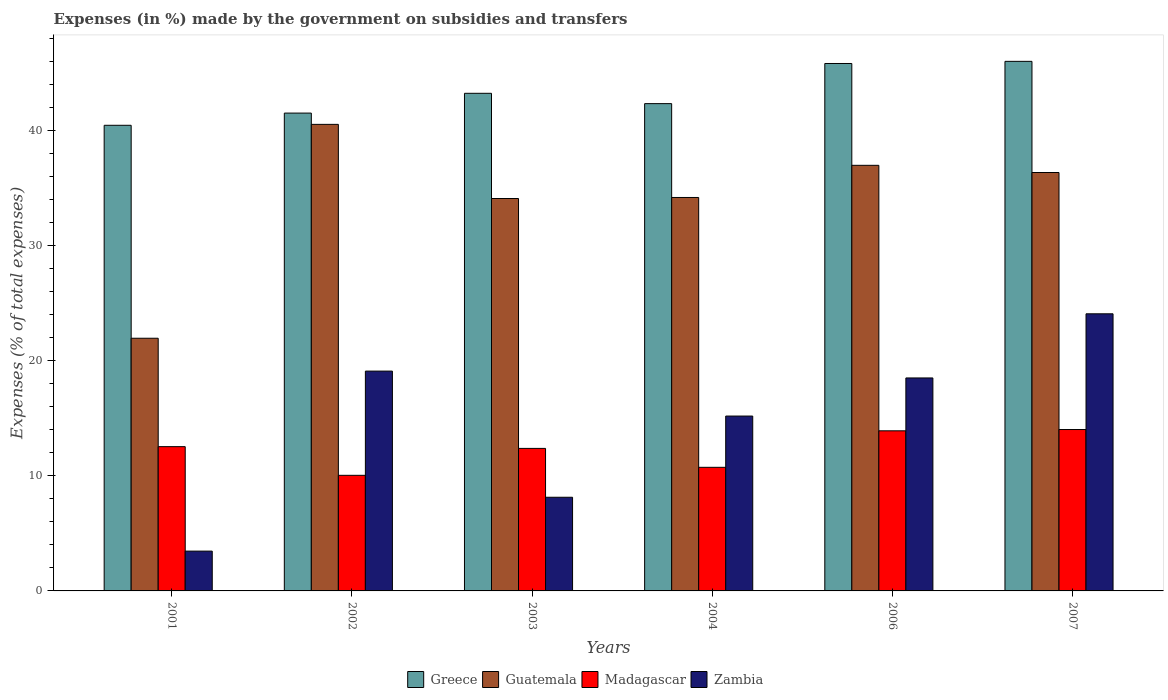How many groups of bars are there?
Your answer should be very brief. 6. Are the number of bars per tick equal to the number of legend labels?
Keep it short and to the point. Yes. How many bars are there on the 3rd tick from the left?
Make the answer very short. 4. What is the percentage of expenses made by the government on subsidies and transfers in Greece in 2007?
Make the answer very short. 46. Across all years, what is the maximum percentage of expenses made by the government on subsidies and transfers in Zambia?
Offer a terse response. 24.07. Across all years, what is the minimum percentage of expenses made by the government on subsidies and transfers in Guatemala?
Your response must be concise. 21.95. In which year was the percentage of expenses made by the government on subsidies and transfers in Zambia maximum?
Keep it short and to the point. 2007. What is the total percentage of expenses made by the government on subsidies and transfers in Zambia in the graph?
Keep it short and to the point. 88.46. What is the difference between the percentage of expenses made by the government on subsidies and transfers in Zambia in 2001 and that in 2006?
Keep it short and to the point. -15.04. What is the difference between the percentage of expenses made by the government on subsidies and transfers in Guatemala in 2003 and the percentage of expenses made by the government on subsidies and transfers in Zambia in 2006?
Provide a short and direct response. 15.59. What is the average percentage of expenses made by the government on subsidies and transfers in Guatemala per year?
Keep it short and to the point. 34.01. In the year 2002, what is the difference between the percentage of expenses made by the government on subsidies and transfers in Zambia and percentage of expenses made by the government on subsidies and transfers in Madagascar?
Ensure brevity in your answer.  9.05. What is the ratio of the percentage of expenses made by the government on subsidies and transfers in Greece in 2001 to that in 2007?
Offer a terse response. 0.88. Is the percentage of expenses made by the government on subsidies and transfers in Guatemala in 2002 less than that in 2004?
Offer a very short reply. No. Is the difference between the percentage of expenses made by the government on subsidies and transfers in Zambia in 2003 and 2006 greater than the difference between the percentage of expenses made by the government on subsidies and transfers in Madagascar in 2003 and 2006?
Make the answer very short. No. What is the difference between the highest and the second highest percentage of expenses made by the government on subsidies and transfers in Guatemala?
Your answer should be compact. 3.56. What is the difference between the highest and the lowest percentage of expenses made by the government on subsidies and transfers in Zambia?
Offer a very short reply. 20.62. What does the 1st bar from the left in 2007 represents?
Your response must be concise. Greece. What does the 2nd bar from the right in 2006 represents?
Give a very brief answer. Madagascar. Is it the case that in every year, the sum of the percentage of expenses made by the government on subsidies and transfers in Madagascar and percentage of expenses made by the government on subsidies and transfers in Greece is greater than the percentage of expenses made by the government on subsidies and transfers in Guatemala?
Provide a succinct answer. Yes. Does the graph contain any zero values?
Offer a very short reply. No. Does the graph contain grids?
Provide a short and direct response. No. What is the title of the graph?
Keep it short and to the point. Expenses (in %) made by the government on subsidies and transfers. What is the label or title of the X-axis?
Your answer should be compact. Years. What is the label or title of the Y-axis?
Provide a succinct answer. Expenses (% of total expenses). What is the Expenses (% of total expenses) in Greece in 2001?
Offer a very short reply. 40.45. What is the Expenses (% of total expenses) in Guatemala in 2001?
Make the answer very short. 21.95. What is the Expenses (% of total expenses) in Madagascar in 2001?
Offer a terse response. 12.53. What is the Expenses (% of total expenses) in Zambia in 2001?
Provide a succinct answer. 3.46. What is the Expenses (% of total expenses) in Greece in 2002?
Give a very brief answer. 41.51. What is the Expenses (% of total expenses) of Guatemala in 2002?
Provide a short and direct response. 40.53. What is the Expenses (% of total expenses) of Madagascar in 2002?
Provide a succinct answer. 10.04. What is the Expenses (% of total expenses) in Zambia in 2002?
Offer a very short reply. 19.1. What is the Expenses (% of total expenses) in Greece in 2003?
Your answer should be compact. 43.23. What is the Expenses (% of total expenses) of Guatemala in 2003?
Provide a short and direct response. 34.09. What is the Expenses (% of total expenses) of Madagascar in 2003?
Provide a short and direct response. 12.38. What is the Expenses (% of total expenses) of Zambia in 2003?
Give a very brief answer. 8.14. What is the Expenses (% of total expenses) in Greece in 2004?
Provide a succinct answer. 42.33. What is the Expenses (% of total expenses) of Guatemala in 2004?
Offer a terse response. 34.18. What is the Expenses (% of total expenses) of Madagascar in 2004?
Give a very brief answer. 10.74. What is the Expenses (% of total expenses) of Zambia in 2004?
Make the answer very short. 15.19. What is the Expenses (% of total expenses) of Greece in 2006?
Provide a succinct answer. 45.82. What is the Expenses (% of total expenses) of Guatemala in 2006?
Offer a very short reply. 36.97. What is the Expenses (% of total expenses) of Madagascar in 2006?
Provide a short and direct response. 13.91. What is the Expenses (% of total expenses) of Zambia in 2006?
Your response must be concise. 18.5. What is the Expenses (% of total expenses) in Greece in 2007?
Your answer should be very brief. 46. What is the Expenses (% of total expenses) in Guatemala in 2007?
Provide a succinct answer. 36.35. What is the Expenses (% of total expenses) in Madagascar in 2007?
Offer a terse response. 14.02. What is the Expenses (% of total expenses) of Zambia in 2007?
Ensure brevity in your answer.  24.07. Across all years, what is the maximum Expenses (% of total expenses) in Greece?
Offer a very short reply. 46. Across all years, what is the maximum Expenses (% of total expenses) of Guatemala?
Keep it short and to the point. 40.53. Across all years, what is the maximum Expenses (% of total expenses) of Madagascar?
Make the answer very short. 14.02. Across all years, what is the maximum Expenses (% of total expenses) of Zambia?
Keep it short and to the point. 24.07. Across all years, what is the minimum Expenses (% of total expenses) of Greece?
Provide a succinct answer. 40.45. Across all years, what is the minimum Expenses (% of total expenses) of Guatemala?
Offer a terse response. 21.95. Across all years, what is the minimum Expenses (% of total expenses) in Madagascar?
Give a very brief answer. 10.04. Across all years, what is the minimum Expenses (% of total expenses) in Zambia?
Offer a very short reply. 3.46. What is the total Expenses (% of total expenses) in Greece in the graph?
Provide a short and direct response. 259.35. What is the total Expenses (% of total expenses) of Guatemala in the graph?
Provide a succinct answer. 204.07. What is the total Expenses (% of total expenses) in Madagascar in the graph?
Your answer should be very brief. 73.62. What is the total Expenses (% of total expenses) in Zambia in the graph?
Ensure brevity in your answer.  88.46. What is the difference between the Expenses (% of total expenses) in Greece in 2001 and that in 2002?
Provide a succinct answer. -1.06. What is the difference between the Expenses (% of total expenses) of Guatemala in 2001 and that in 2002?
Ensure brevity in your answer.  -18.58. What is the difference between the Expenses (% of total expenses) in Madagascar in 2001 and that in 2002?
Your response must be concise. 2.49. What is the difference between the Expenses (% of total expenses) in Zambia in 2001 and that in 2002?
Make the answer very short. -15.64. What is the difference between the Expenses (% of total expenses) in Greece in 2001 and that in 2003?
Your answer should be very brief. -2.78. What is the difference between the Expenses (% of total expenses) in Guatemala in 2001 and that in 2003?
Your answer should be very brief. -12.14. What is the difference between the Expenses (% of total expenses) of Madagascar in 2001 and that in 2003?
Your response must be concise. 0.15. What is the difference between the Expenses (% of total expenses) of Zambia in 2001 and that in 2003?
Provide a short and direct response. -4.68. What is the difference between the Expenses (% of total expenses) of Greece in 2001 and that in 2004?
Provide a short and direct response. -1.88. What is the difference between the Expenses (% of total expenses) in Guatemala in 2001 and that in 2004?
Offer a terse response. -12.23. What is the difference between the Expenses (% of total expenses) in Madagascar in 2001 and that in 2004?
Provide a succinct answer. 1.8. What is the difference between the Expenses (% of total expenses) of Zambia in 2001 and that in 2004?
Give a very brief answer. -11.73. What is the difference between the Expenses (% of total expenses) of Greece in 2001 and that in 2006?
Ensure brevity in your answer.  -5.37. What is the difference between the Expenses (% of total expenses) in Guatemala in 2001 and that in 2006?
Offer a very short reply. -15.02. What is the difference between the Expenses (% of total expenses) in Madagascar in 2001 and that in 2006?
Your answer should be compact. -1.38. What is the difference between the Expenses (% of total expenses) of Zambia in 2001 and that in 2006?
Ensure brevity in your answer.  -15.04. What is the difference between the Expenses (% of total expenses) of Greece in 2001 and that in 2007?
Your answer should be compact. -5.55. What is the difference between the Expenses (% of total expenses) in Guatemala in 2001 and that in 2007?
Provide a short and direct response. -14.4. What is the difference between the Expenses (% of total expenses) of Madagascar in 2001 and that in 2007?
Offer a very short reply. -1.49. What is the difference between the Expenses (% of total expenses) in Zambia in 2001 and that in 2007?
Your answer should be very brief. -20.62. What is the difference between the Expenses (% of total expenses) of Greece in 2002 and that in 2003?
Keep it short and to the point. -1.72. What is the difference between the Expenses (% of total expenses) of Guatemala in 2002 and that in 2003?
Your answer should be compact. 6.44. What is the difference between the Expenses (% of total expenses) of Madagascar in 2002 and that in 2003?
Your answer should be compact. -2.34. What is the difference between the Expenses (% of total expenses) in Zambia in 2002 and that in 2003?
Ensure brevity in your answer.  10.96. What is the difference between the Expenses (% of total expenses) of Greece in 2002 and that in 2004?
Offer a very short reply. -0.82. What is the difference between the Expenses (% of total expenses) in Guatemala in 2002 and that in 2004?
Keep it short and to the point. 6.35. What is the difference between the Expenses (% of total expenses) in Madagascar in 2002 and that in 2004?
Make the answer very short. -0.7. What is the difference between the Expenses (% of total expenses) in Zambia in 2002 and that in 2004?
Offer a terse response. 3.91. What is the difference between the Expenses (% of total expenses) of Greece in 2002 and that in 2006?
Give a very brief answer. -4.31. What is the difference between the Expenses (% of total expenses) of Guatemala in 2002 and that in 2006?
Provide a succinct answer. 3.56. What is the difference between the Expenses (% of total expenses) in Madagascar in 2002 and that in 2006?
Your answer should be compact. -3.87. What is the difference between the Expenses (% of total expenses) of Zambia in 2002 and that in 2006?
Give a very brief answer. 0.6. What is the difference between the Expenses (% of total expenses) in Greece in 2002 and that in 2007?
Keep it short and to the point. -4.49. What is the difference between the Expenses (% of total expenses) in Guatemala in 2002 and that in 2007?
Ensure brevity in your answer.  4.18. What is the difference between the Expenses (% of total expenses) in Madagascar in 2002 and that in 2007?
Offer a very short reply. -3.98. What is the difference between the Expenses (% of total expenses) of Zambia in 2002 and that in 2007?
Keep it short and to the point. -4.98. What is the difference between the Expenses (% of total expenses) of Greece in 2003 and that in 2004?
Your response must be concise. 0.9. What is the difference between the Expenses (% of total expenses) in Guatemala in 2003 and that in 2004?
Make the answer very short. -0.09. What is the difference between the Expenses (% of total expenses) of Madagascar in 2003 and that in 2004?
Your response must be concise. 1.64. What is the difference between the Expenses (% of total expenses) in Zambia in 2003 and that in 2004?
Your response must be concise. -7.05. What is the difference between the Expenses (% of total expenses) in Greece in 2003 and that in 2006?
Your answer should be compact. -2.59. What is the difference between the Expenses (% of total expenses) of Guatemala in 2003 and that in 2006?
Your response must be concise. -2.88. What is the difference between the Expenses (% of total expenses) of Madagascar in 2003 and that in 2006?
Provide a short and direct response. -1.53. What is the difference between the Expenses (% of total expenses) of Zambia in 2003 and that in 2006?
Make the answer very short. -10.36. What is the difference between the Expenses (% of total expenses) in Greece in 2003 and that in 2007?
Your response must be concise. -2.78. What is the difference between the Expenses (% of total expenses) in Guatemala in 2003 and that in 2007?
Make the answer very short. -2.26. What is the difference between the Expenses (% of total expenses) in Madagascar in 2003 and that in 2007?
Offer a terse response. -1.64. What is the difference between the Expenses (% of total expenses) of Zambia in 2003 and that in 2007?
Provide a succinct answer. -15.94. What is the difference between the Expenses (% of total expenses) in Greece in 2004 and that in 2006?
Your response must be concise. -3.49. What is the difference between the Expenses (% of total expenses) of Guatemala in 2004 and that in 2006?
Ensure brevity in your answer.  -2.79. What is the difference between the Expenses (% of total expenses) in Madagascar in 2004 and that in 2006?
Ensure brevity in your answer.  -3.17. What is the difference between the Expenses (% of total expenses) in Zambia in 2004 and that in 2006?
Your answer should be very brief. -3.31. What is the difference between the Expenses (% of total expenses) of Greece in 2004 and that in 2007?
Give a very brief answer. -3.67. What is the difference between the Expenses (% of total expenses) of Guatemala in 2004 and that in 2007?
Keep it short and to the point. -2.17. What is the difference between the Expenses (% of total expenses) of Madagascar in 2004 and that in 2007?
Your answer should be very brief. -3.28. What is the difference between the Expenses (% of total expenses) in Zambia in 2004 and that in 2007?
Make the answer very short. -8.88. What is the difference between the Expenses (% of total expenses) of Greece in 2006 and that in 2007?
Offer a terse response. -0.19. What is the difference between the Expenses (% of total expenses) in Guatemala in 2006 and that in 2007?
Your answer should be compact. 0.62. What is the difference between the Expenses (% of total expenses) in Madagascar in 2006 and that in 2007?
Make the answer very short. -0.11. What is the difference between the Expenses (% of total expenses) of Zambia in 2006 and that in 2007?
Offer a very short reply. -5.57. What is the difference between the Expenses (% of total expenses) of Greece in 2001 and the Expenses (% of total expenses) of Guatemala in 2002?
Offer a very short reply. -0.08. What is the difference between the Expenses (% of total expenses) in Greece in 2001 and the Expenses (% of total expenses) in Madagascar in 2002?
Your answer should be very brief. 30.41. What is the difference between the Expenses (% of total expenses) of Greece in 2001 and the Expenses (% of total expenses) of Zambia in 2002?
Your answer should be compact. 21.35. What is the difference between the Expenses (% of total expenses) in Guatemala in 2001 and the Expenses (% of total expenses) in Madagascar in 2002?
Give a very brief answer. 11.91. What is the difference between the Expenses (% of total expenses) of Guatemala in 2001 and the Expenses (% of total expenses) of Zambia in 2002?
Provide a succinct answer. 2.85. What is the difference between the Expenses (% of total expenses) in Madagascar in 2001 and the Expenses (% of total expenses) in Zambia in 2002?
Your answer should be compact. -6.56. What is the difference between the Expenses (% of total expenses) of Greece in 2001 and the Expenses (% of total expenses) of Guatemala in 2003?
Your answer should be compact. 6.36. What is the difference between the Expenses (% of total expenses) in Greece in 2001 and the Expenses (% of total expenses) in Madagascar in 2003?
Provide a short and direct response. 28.07. What is the difference between the Expenses (% of total expenses) in Greece in 2001 and the Expenses (% of total expenses) in Zambia in 2003?
Your answer should be very brief. 32.31. What is the difference between the Expenses (% of total expenses) of Guatemala in 2001 and the Expenses (% of total expenses) of Madagascar in 2003?
Keep it short and to the point. 9.57. What is the difference between the Expenses (% of total expenses) of Guatemala in 2001 and the Expenses (% of total expenses) of Zambia in 2003?
Provide a succinct answer. 13.81. What is the difference between the Expenses (% of total expenses) in Madagascar in 2001 and the Expenses (% of total expenses) in Zambia in 2003?
Offer a very short reply. 4.4. What is the difference between the Expenses (% of total expenses) in Greece in 2001 and the Expenses (% of total expenses) in Guatemala in 2004?
Your answer should be very brief. 6.27. What is the difference between the Expenses (% of total expenses) of Greece in 2001 and the Expenses (% of total expenses) of Madagascar in 2004?
Give a very brief answer. 29.71. What is the difference between the Expenses (% of total expenses) of Greece in 2001 and the Expenses (% of total expenses) of Zambia in 2004?
Ensure brevity in your answer.  25.26. What is the difference between the Expenses (% of total expenses) of Guatemala in 2001 and the Expenses (% of total expenses) of Madagascar in 2004?
Keep it short and to the point. 11.21. What is the difference between the Expenses (% of total expenses) in Guatemala in 2001 and the Expenses (% of total expenses) in Zambia in 2004?
Ensure brevity in your answer.  6.76. What is the difference between the Expenses (% of total expenses) in Madagascar in 2001 and the Expenses (% of total expenses) in Zambia in 2004?
Provide a succinct answer. -2.66. What is the difference between the Expenses (% of total expenses) in Greece in 2001 and the Expenses (% of total expenses) in Guatemala in 2006?
Offer a terse response. 3.48. What is the difference between the Expenses (% of total expenses) of Greece in 2001 and the Expenses (% of total expenses) of Madagascar in 2006?
Provide a short and direct response. 26.54. What is the difference between the Expenses (% of total expenses) of Greece in 2001 and the Expenses (% of total expenses) of Zambia in 2006?
Make the answer very short. 21.95. What is the difference between the Expenses (% of total expenses) of Guatemala in 2001 and the Expenses (% of total expenses) of Madagascar in 2006?
Keep it short and to the point. 8.04. What is the difference between the Expenses (% of total expenses) in Guatemala in 2001 and the Expenses (% of total expenses) in Zambia in 2006?
Ensure brevity in your answer.  3.45. What is the difference between the Expenses (% of total expenses) of Madagascar in 2001 and the Expenses (% of total expenses) of Zambia in 2006?
Provide a succinct answer. -5.97. What is the difference between the Expenses (% of total expenses) of Greece in 2001 and the Expenses (% of total expenses) of Guatemala in 2007?
Give a very brief answer. 4.1. What is the difference between the Expenses (% of total expenses) in Greece in 2001 and the Expenses (% of total expenses) in Madagascar in 2007?
Make the answer very short. 26.43. What is the difference between the Expenses (% of total expenses) in Greece in 2001 and the Expenses (% of total expenses) in Zambia in 2007?
Provide a succinct answer. 16.38. What is the difference between the Expenses (% of total expenses) in Guatemala in 2001 and the Expenses (% of total expenses) in Madagascar in 2007?
Keep it short and to the point. 7.93. What is the difference between the Expenses (% of total expenses) of Guatemala in 2001 and the Expenses (% of total expenses) of Zambia in 2007?
Give a very brief answer. -2.12. What is the difference between the Expenses (% of total expenses) of Madagascar in 2001 and the Expenses (% of total expenses) of Zambia in 2007?
Provide a short and direct response. -11.54. What is the difference between the Expenses (% of total expenses) of Greece in 2002 and the Expenses (% of total expenses) of Guatemala in 2003?
Provide a succinct answer. 7.42. What is the difference between the Expenses (% of total expenses) of Greece in 2002 and the Expenses (% of total expenses) of Madagascar in 2003?
Your answer should be compact. 29.13. What is the difference between the Expenses (% of total expenses) of Greece in 2002 and the Expenses (% of total expenses) of Zambia in 2003?
Your response must be concise. 33.37. What is the difference between the Expenses (% of total expenses) of Guatemala in 2002 and the Expenses (% of total expenses) of Madagascar in 2003?
Offer a very short reply. 28.15. What is the difference between the Expenses (% of total expenses) of Guatemala in 2002 and the Expenses (% of total expenses) of Zambia in 2003?
Make the answer very short. 32.39. What is the difference between the Expenses (% of total expenses) in Madagascar in 2002 and the Expenses (% of total expenses) in Zambia in 2003?
Make the answer very short. 1.91. What is the difference between the Expenses (% of total expenses) in Greece in 2002 and the Expenses (% of total expenses) in Guatemala in 2004?
Provide a succinct answer. 7.33. What is the difference between the Expenses (% of total expenses) in Greece in 2002 and the Expenses (% of total expenses) in Madagascar in 2004?
Ensure brevity in your answer.  30.77. What is the difference between the Expenses (% of total expenses) in Greece in 2002 and the Expenses (% of total expenses) in Zambia in 2004?
Ensure brevity in your answer.  26.32. What is the difference between the Expenses (% of total expenses) of Guatemala in 2002 and the Expenses (% of total expenses) of Madagascar in 2004?
Make the answer very short. 29.79. What is the difference between the Expenses (% of total expenses) of Guatemala in 2002 and the Expenses (% of total expenses) of Zambia in 2004?
Give a very brief answer. 25.34. What is the difference between the Expenses (% of total expenses) in Madagascar in 2002 and the Expenses (% of total expenses) in Zambia in 2004?
Your answer should be compact. -5.15. What is the difference between the Expenses (% of total expenses) of Greece in 2002 and the Expenses (% of total expenses) of Guatemala in 2006?
Your answer should be compact. 4.54. What is the difference between the Expenses (% of total expenses) in Greece in 2002 and the Expenses (% of total expenses) in Madagascar in 2006?
Ensure brevity in your answer.  27.6. What is the difference between the Expenses (% of total expenses) in Greece in 2002 and the Expenses (% of total expenses) in Zambia in 2006?
Make the answer very short. 23.01. What is the difference between the Expenses (% of total expenses) of Guatemala in 2002 and the Expenses (% of total expenses) of Madagascar in 2006?
Your response must be concise. 26.62. What is the difference between the Expenses (% of total expenses) of Guatemala in 2002 and the Expenses (% of total expenses) of Zambia in 2006?
Your answer should be very brief. 22.03. What is the difference between the Expenses (% of total expenses) of Madagascar in 2002 and the Expenses (% of total expenses) of Zambia in 2006?
Offer a terse response. -8.46. What is the difference between the Expenses (% of total expenses) of Greece in 2002 and the Expenses (% of total expenses) of Guatemala in 2007?
Ensure brevity in your answer.  5.16. What is the difference between the Expenses (% of total expenses) of Greece in 2002 and the Expenses (% of total expenses) of Madagascar in 2007?
Ensure brevity in your answer.  27.49. What is the difference between the Expenses (% of total expenses) in Greece in 2002 and the Expenses (% of total expenses) in Zambia in 2007?
Offer a terse response. 17.44. What is the difference between the Expenses (% of total expenses) in Guatemala in 2002 and the Expenses (% of total expenses) in Madagascar in 2007?
Ensure brevity in your answer.  26.51. What is the difference between the Expenses (% of total expenses) of Guatemala in 2002 and the Expenses (% of total expenses) of Zambia in 2007?
Provide a short and direct response. 16.46. What is the difference between the Expenses (% of total expenses) in Madagascar in 2002 and the Expenses (% of total expenses) in Zambia in 2007?
Provide a short and direct response. -14.03. What is the difference between the Expenses (% of total expenses) in Greece in 2003 and the Expenses (% of total expenses) in Guatemala in 2004?
Your response must be concise. 9.05. What is the difference between the Expenses (% of total expenses) in Greece in 2003 and the Expenses (% of total expenses) in Madagascar in 2004?
Provide a short and direct response. 32.49. What is the difference between the Expenses (% of total expenses) of Greece in 2003 and the Expenses (% of total expenses) of Zambia in 2004?
Your answer should be compact. 28.04. What is the difference between the Expenses (% of total expenses) in Guatemala in 2003 and the Expenses (% of total expenses) in Madagascar in 2004?
Your answer should be very brief. 23.35. What is the difference between the Expenses (% of total expenses) in Guatemala in 2003 and the Expenses (% of total expenses) in Zambia in 2004?
Your answer should be compact. 18.9. What is the difference between the Expenses (% of total expenses) of Madagascar in 2003 and the Expenses (% of total expenses) of Zambia in 2004?
Provide a short and direct response. -2.81. What is the difference between the Expenses (% of total expenses) of Greece in 2003 and the Expenses (% of total expenses) of Guatemala in 2006?
Make the answer very short. 6.26. What is the difference between the Expenses (% of total expenses) in Greece in 2003 and the Expenses (% of total expenses) in Madagascar in 2006?
Offer a very short reply. 29.32. What is the difference between the Expenses (% of total expenses) of Greece in 2003 and the Expenses (% of total expenses) of Zambia in 2006?
Keep it short and to the point. 24.73. What is the difference between the Expenses (% of total expenses) in Guatemala in 2003 and the Expenses (% of total expenses) in Madagascar in 2006?
Provide a succinct answer. 20.18. What is the difference between the Expenses (% of total expenses) in Guatemala in 2003 and the Expenses (% of total expenses) in Zambia in 2006?
Provide a succinct answer. 15.59. What is the difference between the Expenses (% of total expenses) of Madagascar in 2003 and the Expenses (% of total expenses) of Zambia in 2006?
Your answer should be very brief. -6.12. What is the difference between the Expenses (% of total expenses) of Greece in 2003 and the Expenses (% of total expenses) of Guatemala in 2007?
Offer a very short reply. 6.88. What is the difference between the Expenses (% of total expenses) of Greece in 2003 and the Expenses (% of total expenses) of Madagascar in 2007?
Give a very brief answer. 29.21. What is the difference between the Expenses (% of total expenses) in Greece in 2003 and the Expenses (% of total expenses) in Zambia in 2007?
Your answer should be very brief. 19.16. What is the difference between the Expenses (% of total expenses) in Guatemala in 2003 and the Expenses (% of total expenses) in Madagascar in 2007?
Give a very brief answer. 20.07. What is the difference between the Expenses (% of total expenses) in Guatemala in 2003 and the Expenses (% of total expenses) in Zambia in 2007?
Provide a succinct answer. 10.02. What is the difference between the Expenses (% of total expenses) of Madagascar in 2003 and the Expenses (% of total expenses) of Zambia in 2007?
Keep it short and to the point. -11.69. What is the difference between the Expenses (% of total expenses) of Greece in 2004 and the Expenses (% of total expenses) of Guatemala in 2006?
Keep it short and to the point. 5.36. What is the difference between the Expenses (% of total expenses) of Greece in 2004 and the Expenses (% of total expenses) of Madagascar in 2006?
Make the answer very short. 28.42. What is the difference between the Expenses (% of total expenses) of Greece in 2004 and the Expenses (% of total expenses) of Zambia in 2006?
Give a very brief answer. 23.83. What is the difference between the Expenses (% of total expenses) in Guatemala in 2004 and the Expenses (% of total expenses) in Madagascar in 2006?
Provide a succinct answer. 20.27. What is the difference between the Expenses (% of total expenses) in Guatemala in 2004 and the Expenses (% of total expenses) in Zambia in 2006?
Your answer should be very brief. 15.68. What is the difference between the Expenses (% of total expenses) in Madagascar in 2004 and the Expenses (% of total expenses) in Zambia in 2006?
Offer a very short reply. -7.76. What is the difference between the Expenses (% of total expenses) of Greece in 2004 and the Expenses (% of total expenses) of Guatemala in 2007?
Ensure brevity in your answer.  5.98. What is the difference between the Expenses (% of total expenses) in Greece in 2004 and the Expenses (% of total expenses) in Madagascar in 2007?
Your answer should be very brief. 28.31. What is the difference between the Expenses (% of total expenses) in Greece in 2004 and the Expenses (% of total expenses) in Zambia in 2007?
Make the answer very short. 18.26. What is the difference between the Expenses (% of total expenses) of Guatemala in 2004 and the Expenses (% of total expenses) of Madagascar in 2007?
Your response must be concise. 20.16. What is the difference between the Expenses (% of total expenses) of Guatemala in 2004 and the Expenses (% of total expenses) of Zambia in 2007?
Ensure brevity in your answer.  10.11. What is the difference between the Expenses (% of total expenses) of Madagascar in 2004 and the Expenses (% of total expenses) of Zambia in 2007?
Ensure brevity in your answer.  -13.34. What is the difference between the Expenses (% of total expenses) of Greece in 2006 and the Expenses (% of total expenses) of Guatemala in 2007?
Provide a short and direct response. 9.47. What is the difference between the Expenses (% of total expenses) in Greece in 2006 and the Expenses (% of total expenses) in Madagascar in 2007?
Offer a terse response. 31.8. What is the difference between the Expenses (% of total expenses) of Greece in 2006 and the Expenses (% of total expenses) of Zambia in 2007?
Offer a very short reply. 21.74. What is the difference between the Expenses (% of total expenses) in Guatemala in 2006 and the Expenses (% of total expenses) in Madagascar in 2007?
Provide a succinct answer. 22.95. What is the difference between the Expenses (% of total expenses) of Guatemala in 2006 and the Expenses (% of total expenses) of Zambia in 2007?
Give a very brief answer. 12.9. What is the difference between the Expenses (% of total expenses) of Madagascar in 2006 and the Expenses (% of total expenses) of Zambia in 2007?
Keep it short and to the point. -10.17. What is the average Expenses (% of total expenses) of Greece per year?
Offer a very short reply. 43.22. What is the average Expenses (% of total expenses) in Guatemala per year?
Ensure brevity in your answer.  34.01. What is the average Expenses (% of total expenses) of Madagascar per year?
Keep it short and to the point. 12.27. What is the average Expenses (% of total expenses) of Zambia per year?
Keep it short and to the point. 14.74. In the year 2001, what is the difference between the Expenses (% of total expenses) of Greece and Expenses (% of total expenses) of Guatemala?
Provide a short and direct response. 18.5. In the year 2001, what is the difference between the Expenses (% of total expenses) in Greece and Expenses (% of total expenses) in Madagascar?
Your answer should be very brief. 27.92. In the year 2001, what is the difference between the Expenses (% of total expenses) of Greece and Expenses (% of total expenses) of Zambia?
Offer a very short reply. 36.99. In the year 2001, what is the difference between the Expenses (% of total expenses) in Guatemala and Expenses (% of total expenses) in Madagascar?
Ensure brevity in your answer.  9.42. In the year 2001, what is the difference between the Expenses (% of total expenses) in Guatemala and Expenses (% of total expenses) in Zambia?
Keep it short and to the point. 18.49. In the year 2001, what is the difference between the Expenses (% of total expenses) of Madagascar and Expenses (% of total expenses) of Zambia?
Provide a succinct answer. 9.08. In the year 2002, what is the difference between the Expenses (% of total expenses) of Greece and Expenses (% of total expenses) of Guatemala?
Keep it short and to the point. 0.98. In the year 2002, what is the difference between the Expenses (% of total expenses) in Greece and Expenses (% of total expenses) in Madagascar?
Make the answer very short. 31.47. In the year 2002, what is the difference between the Expenses (% of total expenses) of Greece and Expenses (% of total expenses) of Zambia?
Provide a succinct answer. 22.41. In the year 2002, what is the difference between the Expenses (% of total expenses) in Guatemala and Expenses (% of total expenses) in Madagascar?
Offer a terse response. 30.49. In the year 2002, what is the difference between the Expenses (% of total expenses) in Guatemala and Expenses (% of total expenses) in Zambia?
Give a very brief answer. 21.43. In the year 2002, what is the difference between the Expenses (% of total expenses) of Madagascar and Expenses (% of total expenses) of Zambia?
Provide a short and direct response. -9.05. In the year 2003, what is the difference between the Expenses (% of total expenses) in Greece and Expenses (% of total expenses) in Guatemala?
Make the answer very short. 9.14. In the year 2003, what is the difference between the Expenses (% of total expenses) of Greece and Expenses (% of total expenses) of Madagascar?
Ensure brevity in your answer.  30.85. In the year 2003, what is the difference between the Expenses (% of total expenses) in Greece and Expenses (% of total expenses) in Zambia?
Ensure brevity in your answer.  35.09. In the year 2003, what is the difference between the Expenses (% of total expenses) of Guatemala and Expenses (% of total expenses) of Madagascar?
Offer a very short reply. 21.71. In the year 2003, what is the difference between the Expenses (% of total expenses) of Guatemala and Expenses (% of total expenses) of Zambia?
Your answer should be very brief. 25.95. In the year 2003, what is the difference between the Expenses (% of total expenses) of Madagascar and Expenses (% of total expenses) of Zambia?
Your answer should be compact. 4.24. In the year 2004, what is the difference between the Expenses (% of total expenses) in Greece and Expenses (% of total expenses) in Guatemala?
Give a very brief answer. 8.15. In the year 2004, what is the difference between the Expenses (% of total expenses) of Greece and Expenses (% of total expenses) of Madagascar?
Your answer should be very brief. 31.59. In the year 2004, what is the difference between the Expenses (% of total expenses) in Greece and Expenses (% of total expenses) in Zambia?
Your answer should be very brief. 27.14. In the year 2004, what is the difference between the Expenses (% of total expenses) in Guatemala and Expenses (% of total expenses) in Madagascar?
Offer a terse response. 23.44. In the year 2004, what is the difference between the Expenses (% of total expenses) of Guatemala and Expenses (% of total expenses) of Zambia?
Offer a very short reply. 18.99. In the year 2004, what is the difference between the Expenses (% of total expenses) of Madagascar and Expenses (% of total expenses) of Zambia?
Provide a succinct answer. -4.45. In the year 2006, what is the difference between the Expenses (% of total expenses) in Greece and Expenses (% of total expenses) in Guatemala?
Offer a very short reply. 8.85. In the year 2006, what is the difference between the Expenses (% of total expenses) in Greece and Expenses (% of total expenses) in Madagascar?
Your response must be concise. 31.91. In the year 2006, what is the difference between the Expenses (% of total expenses) of Greece and Expenses (% of total expenses) of Zambia?
Provide a succinct answer. 27.32. In the year 2006, what is the difference between the Expenses (% of total expenses) of Guatemala and Expenses (% of total expenses) of Madagascar?
Give a very brief answer. 23.06. In the year 2006, what is the difference between the Expenses (% of total expenses) in Guatemala and Expenses (% of total expenses) in Zambia?
Your answer should be compact. 18.47. In the year 2006, what is the difference between the Expenses (% of total expenses) in Madagascar and Expenses (% of total expenses) in Zambia?
Ensure brevity in your answer.  -4.59. In the year 2007, what is the difference between the Expenses (% of total expenses) in Greece and Expenses (% of total expenses) in Guatemala?
Keep it short and to the point. 9.66. In the year 2007, what is the difference between the Expenses (% of total expenses) in Greece and Expenses (% of total expenses) in Madagascar?
Your response must be concise. 31.98. In the year 2007, what is the difference between the Expenses (% of total expenses) in Greece and Expenses (% of total expenses) in Zambia?
Offer a terse response. 21.93. In the year 2007, what is the difference between the Expenses (% of total expenses) of Guatemala and Expenses (% of total expenses) of Madagascar?
Provide a short and direct response. 22.33. In the year 2007, what is the difference between the Expenses (% of total expenses) in Guatemala and Expenses (% of total expenses) in Zambia?
Offer a terse response. 12.28. In the year 2007, what is the difference between the Expenses (% of total expenses) of Madagascar and Expenses (% of total expenses) of Zambia?
Provide a short and direct response. -10.05. What is the ratio of the Expenses (% of total expenses) of Greece in 2001 to that in 2002?
Provide a succinct answer. 0.97. What is the ratio of the Expenses (% of total expenses) of Guatemala in 2001 to that in 2002?
Provide a succinct answer. 0.54. What is the ratio of the Expenses (% of total expenses) of Madagascar in 2001 to that in 2002?
Offer a terse response. 1.25. What is the ratio of the Expenses (% of total expenses) of Zambia in 2001 to that in 2002?
Provide a short and direct response. 0.18. What is the ratio of the Expenses (% of total expenses) of Greece in 2001 to that in 2003?
Your answer should be very brief. 0.94. What is the ratio of the Expenses (% of total expenses) of Guatemala in 2001 to that in 2003?
Your answer should be very brief. 0.64. What is the ratio of the Expenses (% of total expenses) in Madagascar in 2001 to that in 2003?
Offer a very short reply. 1.01. What is the ratio of the Expenses (% of total expenses) in Zambia in 2001 to that in 2003?
Your answer should be very brief. 0.42. What is the ratio of the Expenses (% of total expenses) of Greece in 2001 to that in 2004?
Make the answer very short. 0.96. What is the ratio of the Expenses (% of total expenses) in Guatemala in 2001 to that in 2004?
Your response must be concise. 0.64. What is the ratio of the Expenses (% of total expenses) in Madagascar in 2001 to that in 2004?
Offer a very short reply. 1.17. What is the ratio of the Expenses (% of total expenses) in Zambia in 2001 to that in 2004?
Make the answer very short. 0.23. What is the ratio of the Expenses (% of total expenses) of Greece in 2001 to that in 2006?
Make the answer very short. 0.88. What is the ratio of the Expenses (% of total expenses) of Guatemala in 2001 to that in 2006?
Provide a succinct answer. 0.59. What is the ratio of the Expenses (% of total expenses) of Madagascar in 2001 to that in 2006?
Offer a terse response. 0.9. What is the ratio of the Expenses (% of total expenses) in Zambia in 2001 to that in 2006?
Give a very brief answer. 0.19. What is the ratio of the Expenses (% of total expenses) in Greece in 2001 to that in 2007?
Make the answer very short. 0.88. What is the ratio of the Expenses (% of total expenses) in Guatemala in 2001 to that in 2007?
Give a very brief answer. 0.6. What is the ratio of the Expenses (% of total expenses) of Madagascar in 2001 to that in 2007?
Offer a terse response. 0.89. What is the ratio of the Expenses (% of total expenses) of Zambia in 2001 to that in 2007?
Your response must be concise. 0.14. What is the ratio of the Expenses (% of total expenses) in Greece in 2002 to that in 2003?
Your answer should be compact. 0.96. What is the ratio of the Expenses (% of total expenses) in Guatemala in 2002 to that in 2003?
Make the answer very short. 1.19. What is the ratio of the Expenses (% of total expenses) in Madagascar in 2002 to that in 2003?
Your answer should be very brief. 0.81. What is the ratio of the Expenses (% of total expenses) in Zambia in 2002 to that in 2003?
Your answer should be very brief. 2.35. What is the ratio of the Expenses (% of total expenses) in Greece in 2002 to that in 2004?
Your answer should be compact. 0.98. What is the ratio of the Expenses (% of total expenses) of Guatemala in 2002 to that in 2004?
Offer a very short reply. 1.19. What is the ratio of the Expenses (% of total expenses) of Madagascar in 2002 to that in 2004?
Provide a short and direct response. 0.94. What is the ratio of the Expenses (% of total expenses) of Zambia in 2002 to that in 2004?
Offer a very short reply. 1.26. What is the ratio of the Expenses (% of total expenses) in Greece in 2002 to that in 2006?
Your answer should be compact. 0.91. What is the ratio of the Expenses (% of total expenses) of Guatemala in 2002 to that in 2006?
Offer a very short reply. 1.1. What is the ratio of the Expenses (% of total expenses) of Madagascar in 2002 to that in 2006?
Provide a succinct answer. 0.72. What is the ratio of the Expenses (% of total expenses) of Zambia in 2002 to that in 2006?
Provide a short and direct response. 1.03. What is the ratio of the Expenses (% of total expenses) in Greece in 2002 to that in 2007?
Keep it short and to the point. 0.9. What is the ratio of the Expenses (% of total expenses) in Guatemala in 2002 to that in 2007?
Provide a succinct answer. 1.11. What is the ratio of the Expenses (% of total expenses) in Madagascar in 2002 to that in 2007?
Provide a short and direct response. 0.72. What is the ratio of the Expenses (% of total expenses) in Zambia in 2002 to that in 2007?
Provide a short and direct response. 0.79. What is the ratio of the Expenses (% of total expenses) of Greece in 2003 to that in 2004?
Your answer should be compact. 1.02. What is the ratio of the Expenses (% of total expenses) of Madagascar in 2003 to that in 2004?
Your answer should be compact. 1.15. What is the ratio of the Expenses (% of total expenses) in Zambia in 2003 to that in 2004?
Your answer should be very brief. 0.54. What is the ratio of the Expenses (% of total expenses) of Greece in 2003 to that in 2006?
Keep it short and to the point. 0.94. What is the ratio of the Expenses (% of total expenses) of Guatemala in 2003 to that in 2006?
Give a very brief answer. 0.92. What is the ratio of the Expenses (% of total expenses) in Madagascar in 2003 to that in 2006?
Your answer should be very brief. 0.89. What is the ratio of the Expenses (% of total expenses) in Zambia in 2003 to that in 2006?
Ensure brevity in your answer.  0.44. What is the ratio of the Expenses (% of total expenses) of Greece in 2003 to that in 2007?
Provide a short and direct response. 0.94. What is the ratio of the Expenses (% of total expenses) in Guatemala in 2003 to that in 2007?
Your answer should be very brief. 0.94. What is the ratio of the Expenses (% of total expenses) in Madagascar in 2003 to that in 2007?
Your answer should be very brief. 0.88. What is the ratio of the Expenses (% of total expenses) of Zambia in 2003 to that in 2007?
Provide a succinct answer. 0.34. What is the ratio of the Expenses (% of total expenses) of Greece in 2004 to that in 2006?
Give a very brief answer. 0.92. What is the ratio of the Expenses (% of total expenses) in Guatemala in 2004 to that in 2006?
Your answer should be very brief. 0.92. What is the ratio of the Expenses (% of total expenses) of Madagascar in 2004 to that in 2006?
Keep it short and to the point. 0.77. What is the ratio of the Expenses (% of total expenses) in Zambia in 2004 to that in 2006?
Provide a succinct answer. 0.82. What is the ratio of the Expenses (% of total expenses) of Greece in 2004 to that in 2007?
Provide a succinct answer. 0.92. What is the ratio of the Expenses (% of total expenses) in Guatemala in 2004 to that in 2007?
Provide a succinct answer. 0.94. What is the ratio of the Expenses (% of total expenses) in Madagascar in 2004 to that in 2007?
Ensure brevity in your answer.  0.77. What is the ratio of the Expenses (% of total expenses) of Zambia in 2004 to that in 2007?
Give a very brief answer. 0.63. What is the ratio of the Expenses (% of total expenses) in Greece in 2006 to that in 2007?
Offer a very short reply. 1. What is the ratio of the Expenses (% of total expenses) in Guatemala in 2006 to that in 2007?
Give a very brief answer. 1.02. What is the ratio of the Expenses (% of total expenses) of Zambia in 2006 to that in 2007?
Give a very brief answer. 0.77. What is the difference between the highest and the second highest Expenses (% of total expenses) in Greece?
Offer a terse response. 0.19. What is the difference between the highest and the second highest Expenses (% of total expenses) of Guatemala?
Provide a succinct answer. 3.56. What is the difference between the highest and the second highest Expenses (% of total expenses) in Madagascar?
Keep it short and to the point. 0.11. What is the difference between the highest and the second highest Expenses (% of total expenses) in Zambia?
Provide a short and direct response. 4.98. What is the difference between the highest and the lowest Expenses (% of total expenses) of Greece?
Your answer should be compact. 5.55. What is the difference between the highest and the lowest Expenses (% of total expenses) in Guatemala?
Ensure brevity in your answer.  18.58. What is the difference between the highest and the lowest Expenses (% of total expenses) in Madagascar?
Ensure brevity in your answer.  3.98. What is the difference between the highest and the lowest Expenses (% of total expenses) in Zambia?
Keep it short and to the point. 20.62. 